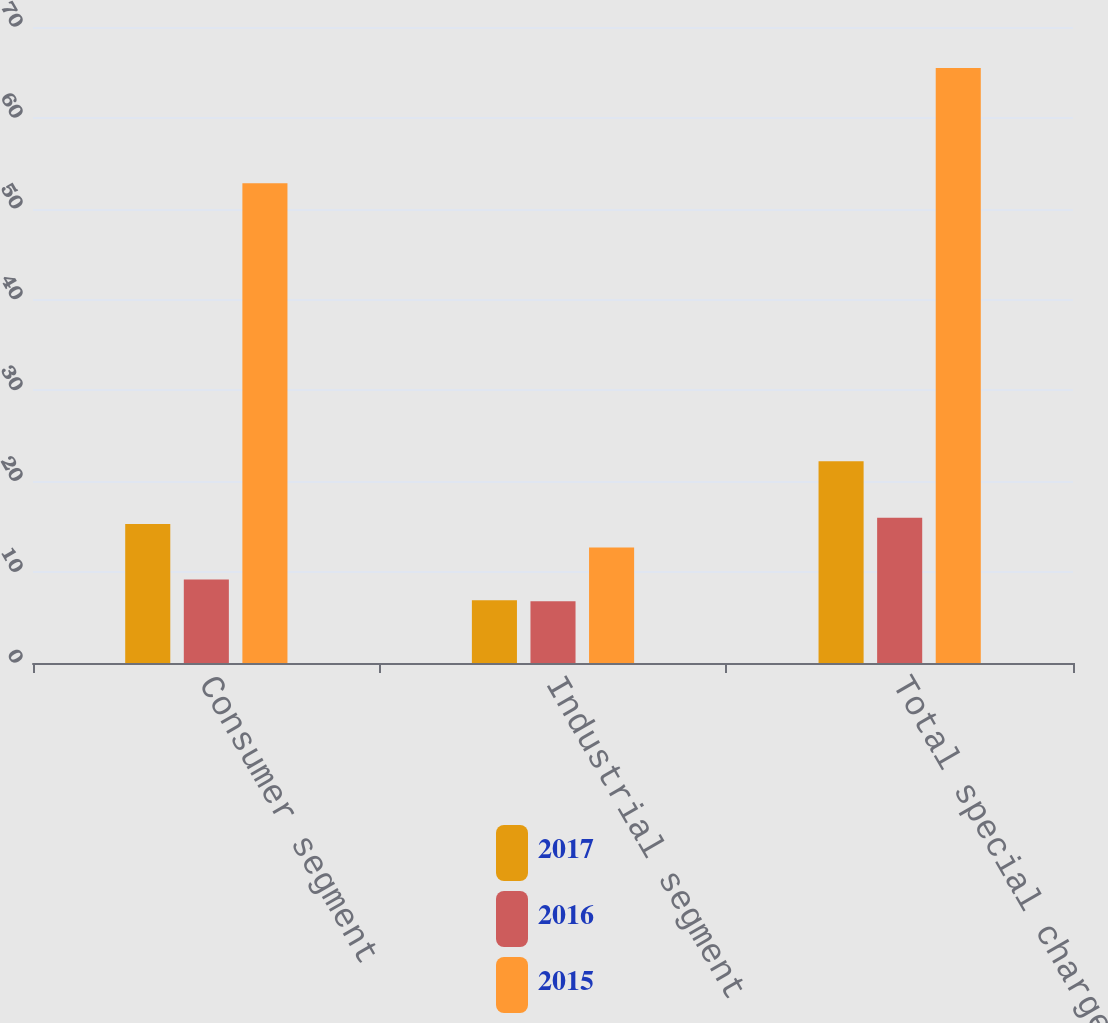Convert chart to OTSL. <chart><loc_0><loc_0><loc_500><loc_500><stacked_bar_chart><ecel><fcel>Consumer segment<fcel>Industrial segment<fcel>Total special charges<nl><fcel>2017<fcel>15.3<fcel>6.9<fcel>22.2<nl><fcel>2016<fcel>9.2<fcel>6.8<fcel>16<nl><fcel>2015<fcel>52.8<fcel>12.7<fcel>65.5<nl></chart> 